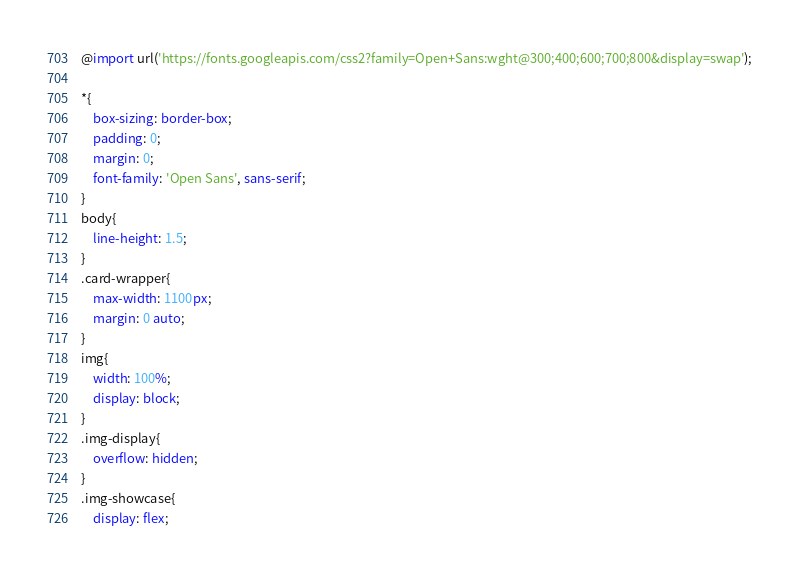<code> <loc_0><loc_0><loc_500><loc_500><_CSS_>@import url('https://fonts.googleapis.com/css2?family=Open+Sans:wght@300;400;600;700;800&display=swap');

*{
    box-sizing: border-box;
    padding: 0;
    margin: 0;
    font-family: 'Open Sans', sans-serif;
}
body{
    line-height: 1.5;
}
.card-wrapper{
    max-width: 1100px;
    margin: 0 auto;
}
img{
    width: 100%;
    display: block;
}
.img-display{
    overflow: hidden;
}
.img-showcase{
    display: flex;</code> 